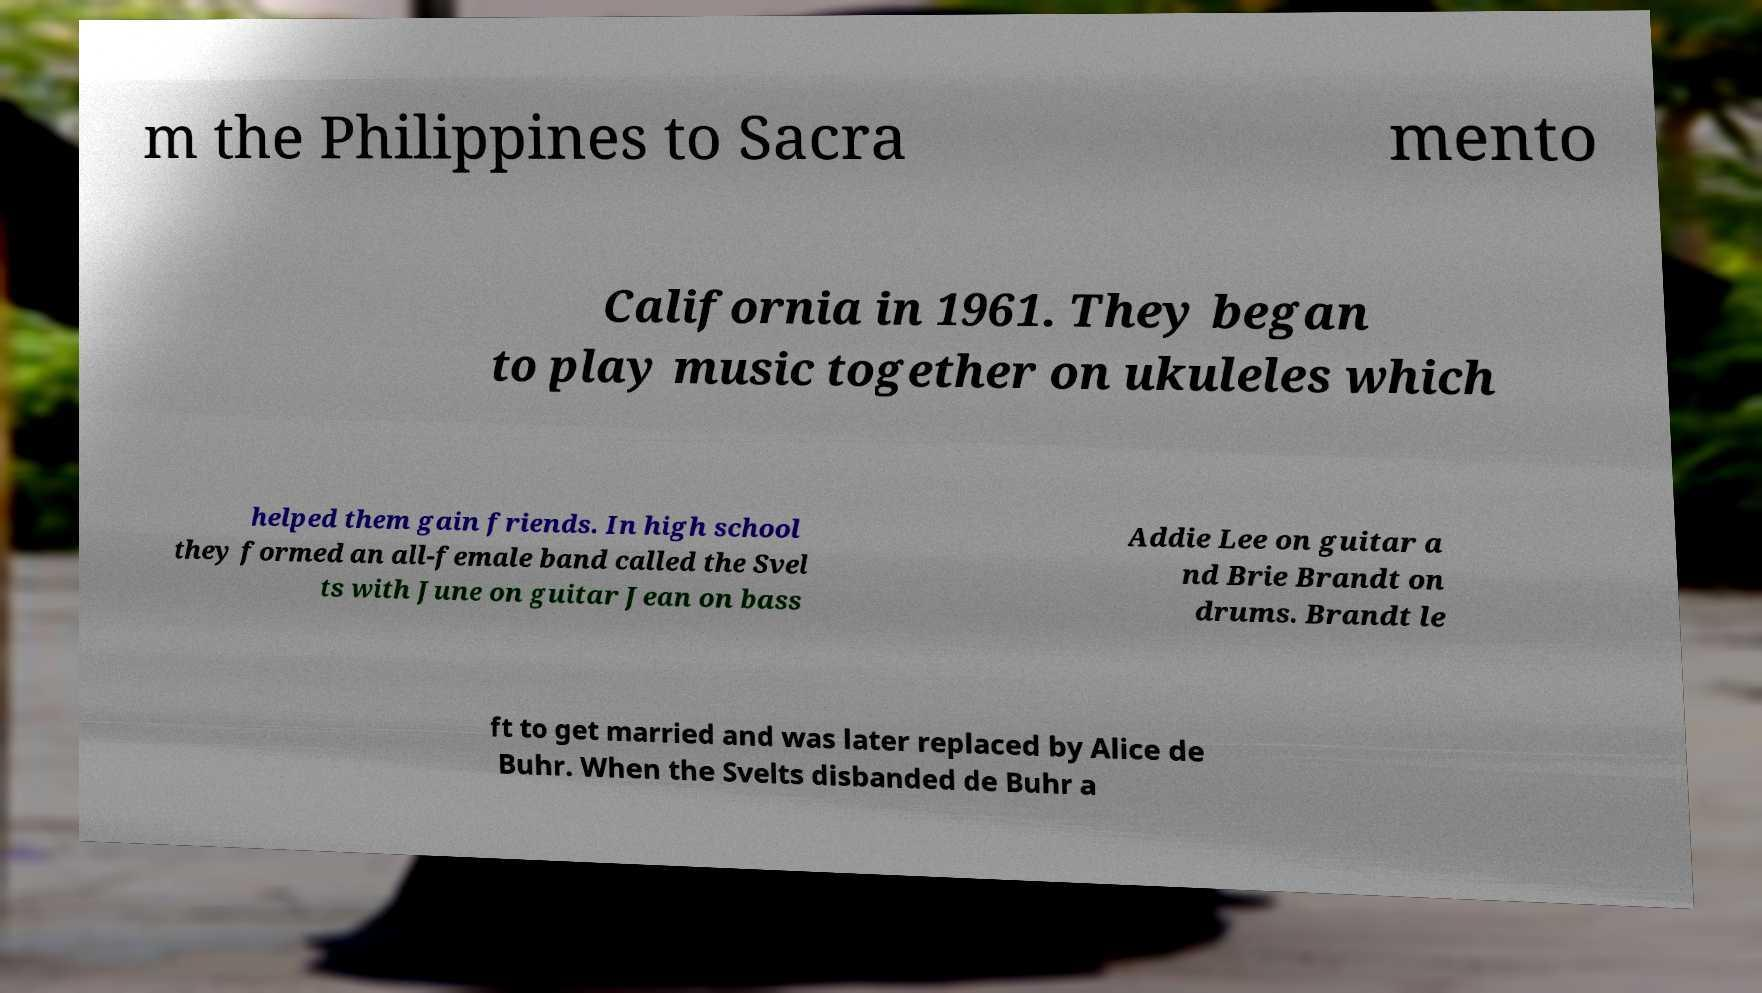Please read and relay the text visible in this image. What does it say? m the Philippines to Sacra mento California in 1961. They began to play music together on ukuleles which helped them gain friends. In high school they formed an all-female band called the Svel ts with June on guitar Jean on bass Addie Lee on guitar a nd Brie Brandt on drums. Brandt le ft to get married and was later replaced by Alice de Buhr. When the Svelts disbanded de Buhr a 